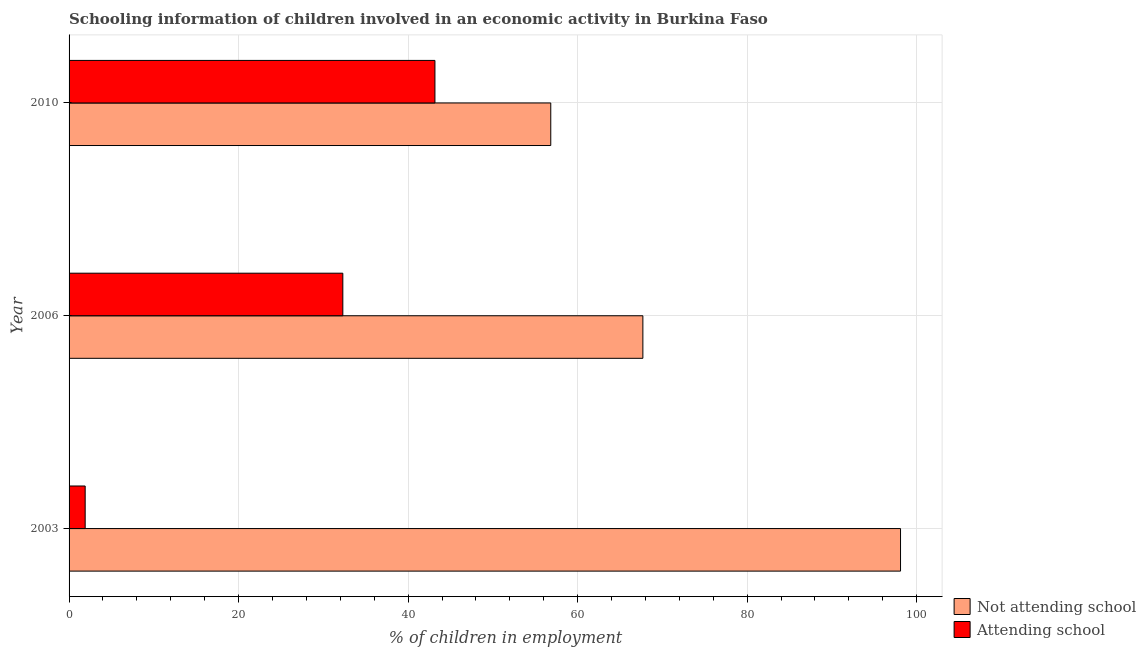How many different coloured bars are there?
Your answer should be very brief. 2. How many bars are there on the 1st tick from the bottom?
Keep it short and to the point. 2. What is the label of the 1st group of bars from the top?
Provide a short and direct response. 2010. What is the percentage of employed children who are attending school in 2006?
Offer a very short reply. 32.3. Across all years, what is the maximum percentage of employed children who are attending school?
Your answer should be very brief. 43.17. In which year was the percentage of employed children who are not attending school maximum?
Keep it short and to the point. 2003. What is the total percentage of employed children who are attending school in the graph?
Keep it short and to the point. 77.37. What is the difference between the percentage of employed children who are attending school in 2006 and that in 2010?
Provide a short and direct response. -10.87. What is the difference between the percentage of employed children who are attending school in 2010 and the percentage of employed children who are not attending school in 2003?
Ensure brevity in your answer.  -54.93. What is the average percentage of employed children who are attending school per year?
Provide a succinct answer. 25.79. In the year 2003, what is the difference between the percentage of employed children who are not attending school and percentage of employed children who are attending school?
Give a very brief answer. 96.2. What is the ratio of the percentage of employed children who are attending school in 2006 to that in 2010?
Offer a terse response. 0.75. Is the percentage of employed children who are attending school in 2003 less than that in 2006?
Keep it short and to the point. Yes. What is the difference between the highest and the second highest percentage of employed children who are attending school?
Your answer should be compact. 10.87. What is the difference between the highest and the lowest percentage of employed children who are not attending school?
Offer a terse response. 41.27. What does the 1st bar from the top in 2010 represents?
Your response must be concise. Attending school. What does the 1st bar from the bottom in 2003 represents?
Provide a short and direct response. Not attending school. How many years are there in the graph?
Provide a succinct answer. 3. What is the difference between two consecutive major ticks on the X-axis?
Give a very brief answer. 20. Are the values on the major ticks of X-axis written in scientific E-notation?
Offer a terse response. No. What is the title of the graph?
Offer a terse response. Schooling information of children involved in an economic activity in Burkina Faso. Does "DAC donors" appear as one of the legend labels in the graph?
Make the answer very short. No. What is the label or title of the X-axis?
Your answer should be very brief. % of children in employment. What is the label or title of the Y-axis?
Keep it short and to the point. Year. What is the % of children in employment of Not attending school in 2003?
Make the answer very short. 98.1. What is the % of children in employment of Not attending school in 2006?
Make the answer very short. 67.7. What is the % of children in employment in Attending school in 2006?
Your answer should be very brief. 32.3. What is the % of children in employment of Not attending school in 2010?
Keep it short and to the point. 56.83. What is the % of children in employment in Attending school in 2010?
Keep it short and to the point. 43.17. Across all years, what is the maximum % of children in employment in Not attending school?
Make the answer very short. 98.1. Across all years, what is the maximum % of children in employment in Attending school?
Offer a very short reply. 43.17. Across all years, what is the minimum % of children in employment of Not attending school?
Ensure brevity in your answer.  56.83. What is the total % of children in employment of Not attending school in the graph?
Provide a succinct answer. 222.63. What is the total % of children in employment of Attending school in the graph?
Your answer should be compact. 77.37. What is the difference between the % of children in employment in Not attending school in 2003 and that in 2006?
Your response must be concise. 30.4. What is the difference between the % of children in employment in Attending school in 2003 and that in 2006?
Keep it short and to the point. -30.4. What is the difference between the % of children in employment in Not attending school in 2003 and that in 2010?
Your answer should be very brief. 41.27. What is the difference between the % of children in employment in Attending school in 2003 and that in 2010?
Ensure brevity in your answer.  -41.27. What is the difference between the % of children in employment of Not attending school in 2006 and that in 2010?
Give a very brief answer. 10.87. What is the difference between the % of children in employment of Attending school in 2006 and that in 2010?
Give a very brief answer. -10.87. What is the difference between the % of children in employment of Not attending school in 2003 and the % of children in employment of Attending school in 2006?
Give a very brief answer. 65.8. What is the difference between the % of children in employment in Not attending school in 2003 and the % of children in employment in Attending school in 2010?
Ensure brevity in your answer.  54.93. What is the difference between the % of children in employment of Not attending school in 2006 and the % of children in employment of Attending school in 2010?
Provide a short and direct response. 24.53. What is the average % of children in employment in Not attending school per year?
Offer a terse response. 74.21. What is the average % of children in employment in Attending school per year?
Offer a very short reply. 25.79. In the year 2003, what is the difference between the % of children in employment in Not attending school and % of children in employment in Attending school?
Provide a succinct answer. 96.2. In the year 2006, what is the difference between the % of children in employment of Not attending school and % of children in employment of Attending school?
Offer a terse response. 35.4. In the year 2010, what is the difference between the % of children in employment of Not attending school and % of children in employment of Attending school?
Your answer should be very brief. 13.67. What is the ratio of the % of children in employment in Not attending school in 2003 to that in 2006?
Ensure brevity in your answer.  1.45. What is the ratio of the % of children in employment of Attending school in 2003 to that in 2006?
Your answer should be compact. 0.06. What is the ratio of the % of children in employment in Not attending school in 2003 to that in 2010?
Provide a succinct answer. 1.73. What is the ratio of the % of children in employment in Attending school in 2003 to that in 2010?
Provide a succinct answer. 0.04. What is the ratio of the % of children in employment in Not attending school in 2006 to that in 2010?
Your response must be concise. 1.19. What is the ratio of the % of children in employment of Attending school in 2006 to that in 2010?
Offer a terse response. 0.75. What is the difference between the highest and the second highest % of children in employment in Not attending school?
Provide a short and direct response. 30.4. What is the difference between the highest and the second highest % of children in employment of Attending school?
Offer a terse response. 10.87. What is the difference between the highest and the lowest % of children in employment in Not attending school?
Keep it short and to the point. 41.27. What is the difference between the highest and the lowest % of children in employment in Attending school?
Your answer should be compact. 41.27. 